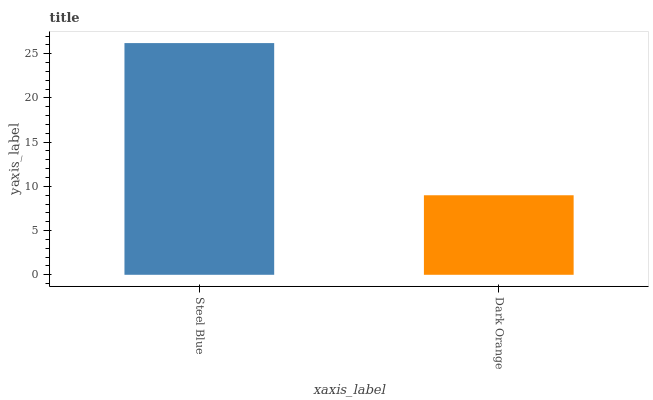Is Dark Orange the minimum?
Answer yes or no. Yes. Is Steel Blue the maximum?
Answer yes or no. Yes. Is Dark Orange the maximum?
Answer yes or no. No. Is Steel Blue greater than Dark Orange?
Answer yes or no. Yes. Is Dark Orange less than Steel Blue?
Answer yes or no. Yes. Is Dark Orange greater than Steel Blue?
Answer yes or no. No. Is Steel Blue less than Dark Orange?
Answer yes or no. No. Is Steel Blue the high median?
Answer yes or no. Yes. Is Dark Orange the low median?
Answer yes or no. Yes. Is Dark Orange the high median?
Answer yes or no. No. Is Steel Blue the low median?
Answer yes or no. No. 